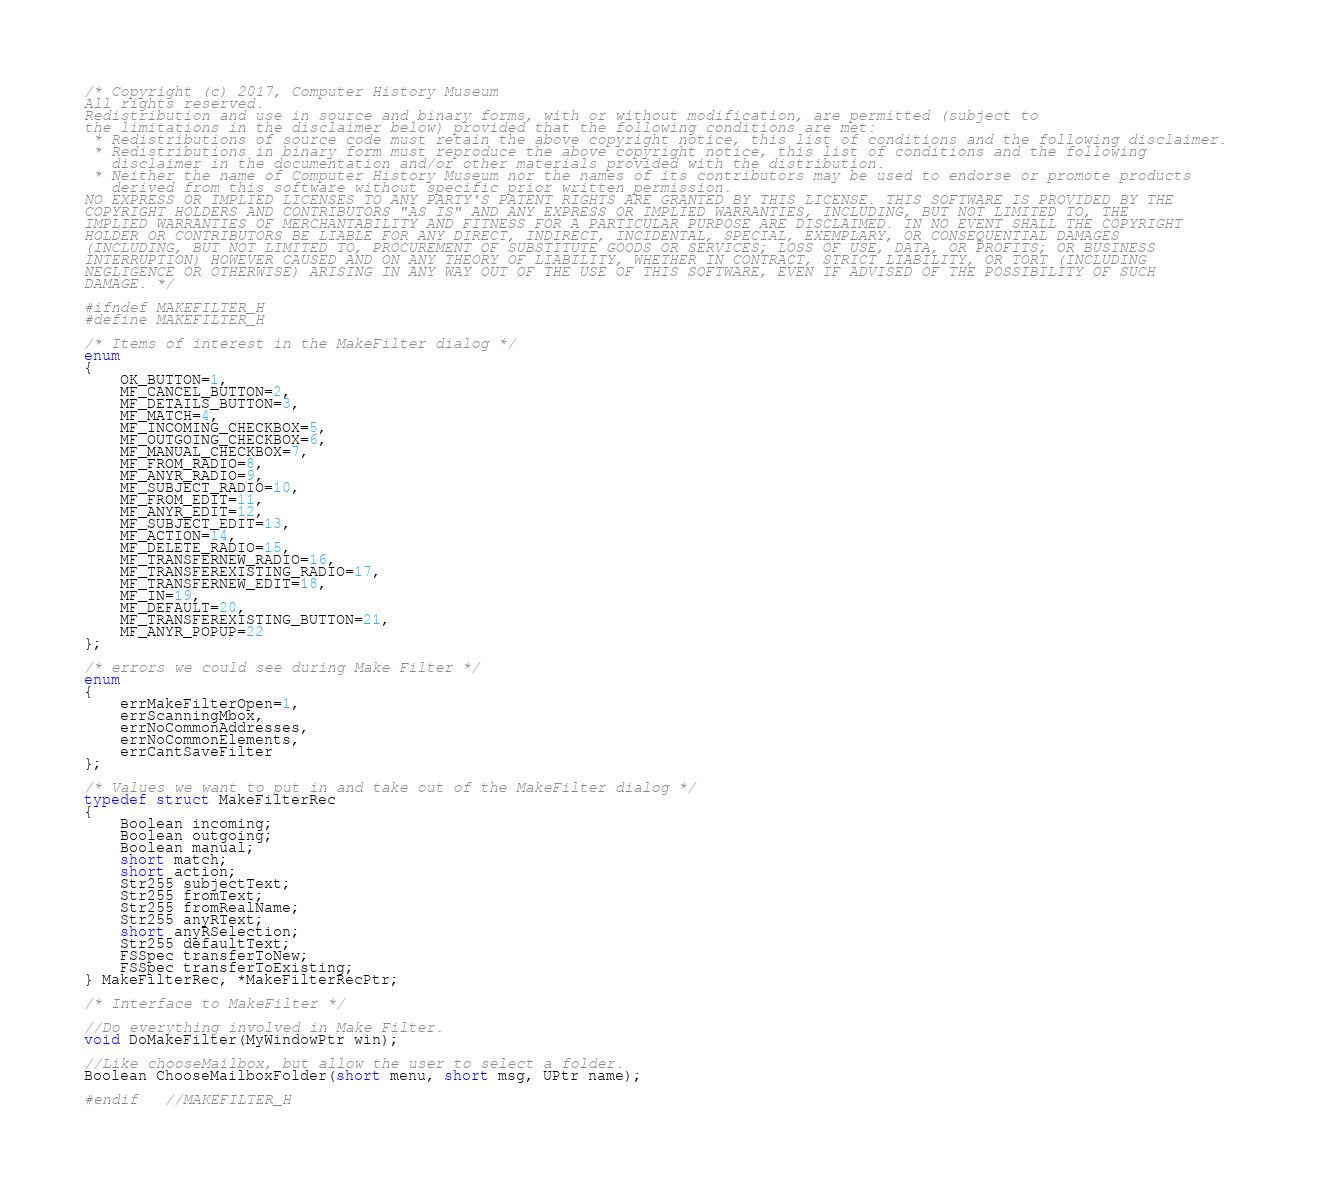Convert code to text. <code><loc_0><loc_0><loc_500><loc_500><_C_>/* Copyright (c) 2017, Computer History Museum All rights reserved. Redistribution and use in source and binary forms, with or without modification, are permitted (subject to the limitations in the disclaimer below) provided that the following conditions are met:  * Redistributions of source code must retain the above copyright notice, this list of conditions and the following disclaimer.  * Redistributions in binary form must reproduce the above copyright notice, this list of conditions and the following    disclaimer in the documentation and/or other materials provided with the distribution.  * Neither the name of Computer History Museum nor the names of its contributors may be used to endorse or promote products    derived from this software without specific prior written permission. NO EXPRESS OR IMPLIED LICENSES TO ANY PARTY'S PATENT RIGHTS ARE GRANTED BY THIS LICENSE. THIS SOFTWARE IS PROVIDED BY THE COPYRIGHT HOLDERS AND CONTRIBUTORS "AS IS" AND ANY EXPRESS OR IMPLIED WARRANTIES, INCLUDING, BUT NOT LIMITED TO, THE IMPLIED WARRANTIES OF MERCHANTABILITY AND FITNESS FOR A PARTICULAR PURPOSE ARE DISCLAIMED. IN NO EVENT SHALL THE COPYRIGHT HOLDER OR CONTRIBUTORS BE LIABLE FOR ANY DIRECT, INDIRECT, INCIDENTAL, SPECIAL, EXEMPLARY, OR CONSEQUENTIAL DAMAGES (INCLUDING, BUT NOT LIMITED TO, PROCUREMENT OF SUBSTITUTE GOODS OR SERVICES; LOSS OF USE, DATA, OR PROFITS; OR BUSINESS INTERRUPTION) HOWEVER CAUSED AND ON ANY THEORY OF LIABILITY, WHETHER IN CONTRACT, STRICT LIABILITY, OR TORT (INCLUDING NEGLIGENCE OR OTHERWISE) ARISING IN ANY WAY OUT OF THE USE OF THIS SOFTWARE, EVEN IF ADVISED OF THE POSSIBILITY OF SUCH DAMAGE. */#ifndef MAKEFILTER_H#define MAKEFILTER_H/* Items of interest in the MakeFilter dialog */enum{	OK_BUTTON=1,	MF_CANCEL_BUTTON=2,	MF_DETAILS_BUTTON=3,	MF_MATCH=4,	MF_INCOMING_CHECKBOX=5,	MF_OUTGOING_CHECKBOX=6,	MF_MANUAL_CHECKBOX=7,	MF_FROM_RADIO=8,	MF_ANYR_RADIO=9,	MF_SUBJECT_RADIO=10,	MF_FROM_EDIT=11,	MF_ANYR_EDIT=12,	MF_SUBJECT_EDIT=13,	MF_ACTION=14,	MF_DELETE_RADIO=15,	MF_TRANSFERNEW_RADIO=16,	MF_TRANSFEREXISTING_RADIO=17,	MF_TRANSFERNEW_EDIT=18,	MF_IN=19,	MF_DEFAULT=20,	MF_TRANSFEREXISTING_BUTTON=21,	MF_ANYR_POPUP=22};/* errors we could see during Make Filter */enum{	errMakeFilterOpen=1,	errScanningMbox,	errNoCommonAddresses,	errNoCommonElements,	errCantSaveFilter};/* Values we want to put in and take out of the MakeFilter dialog */typedef struct MakeFilterRec{	Boolean incoming;	Boolean outgoing;	Boolean manual;	short match;	short action;	Str255 subjectText;	Str255 fromText;	Str255 fromRealName;	Str255 anyRText;	short anyRSelection;	Str255 defaultText;	FSSpec transferToNew;	FSSpec transferToExisting;} MakeFilterRec, *MakeFilterRecPtr;/* Interface to MakeFilter *///Do everything involved in Make Filter.void DoMakeFilter(MyWindowPtr win);	//Like chooseMailbox, but allow the user to select a folder.Boolean ChooseMailboxFolder(short menu, short msg, UPtr name);#endif	//MAKEFILTER_H</code> 